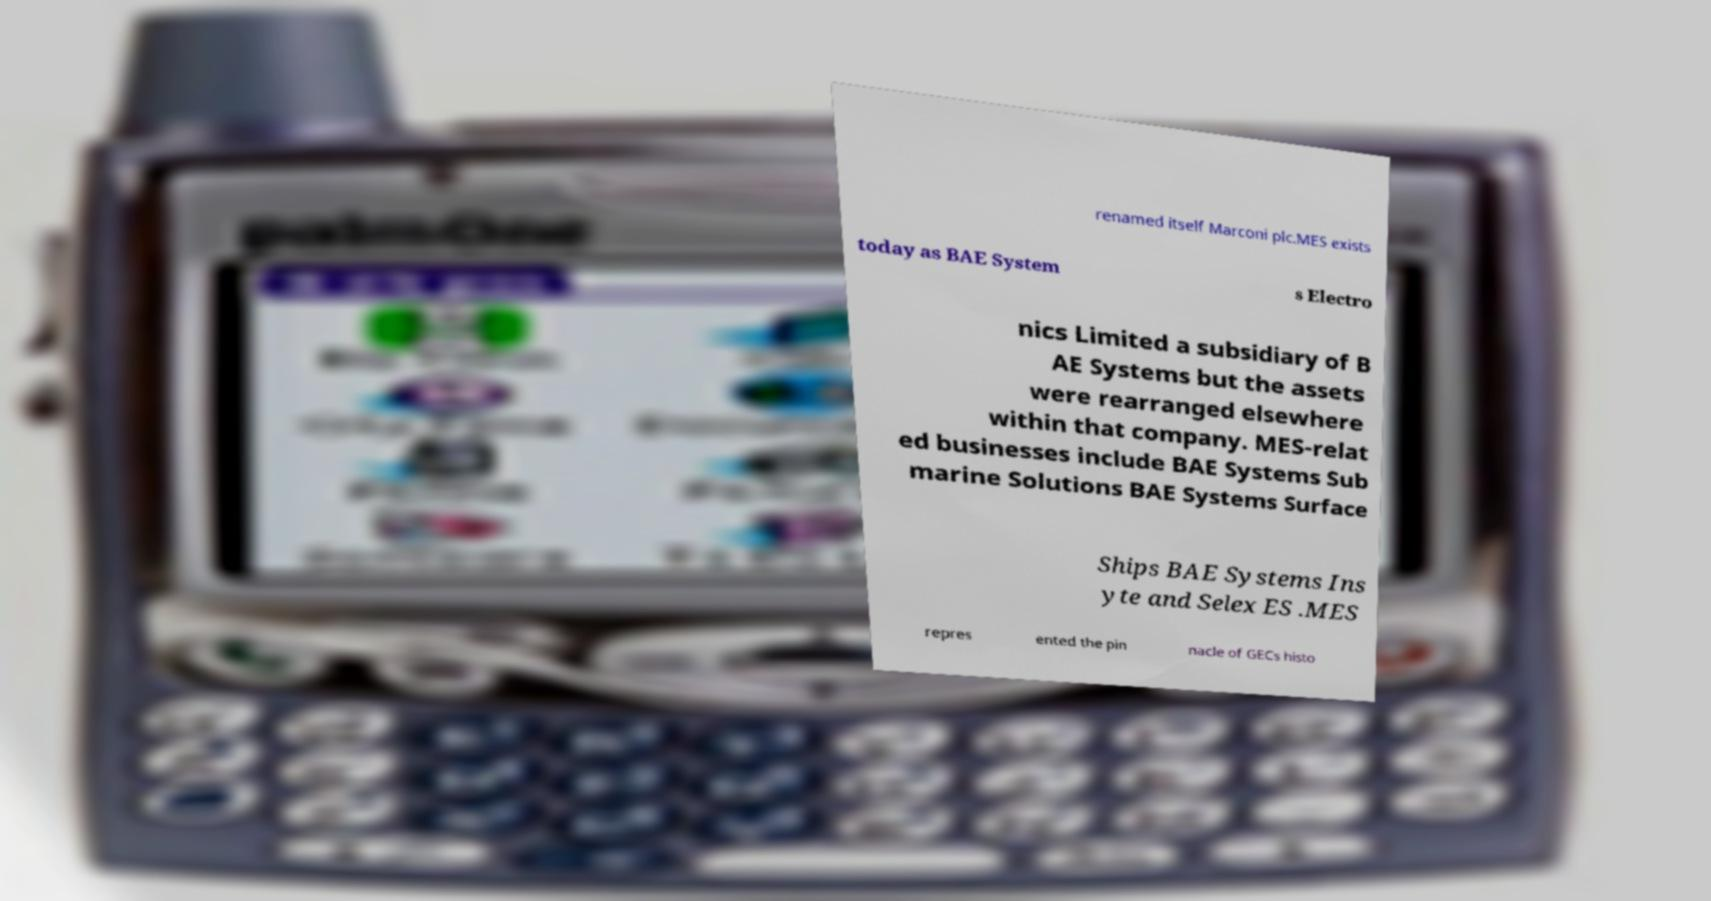There's text embedded in this image that I need extracted. Can you transcribe it verbatim? renamed itself Marconi plc.MES exists today as BAE System s Electro nics Limited a subsidiary of B AE Systems but the assets were rearranged elsewhere within that company. MES-relat ed businesses include BAE Systems Sub marine Solutions BAE Systems Surface Ships BAE Systems Ins yte and Selex ES .MES repres ented the pin nacle of GECs histo 